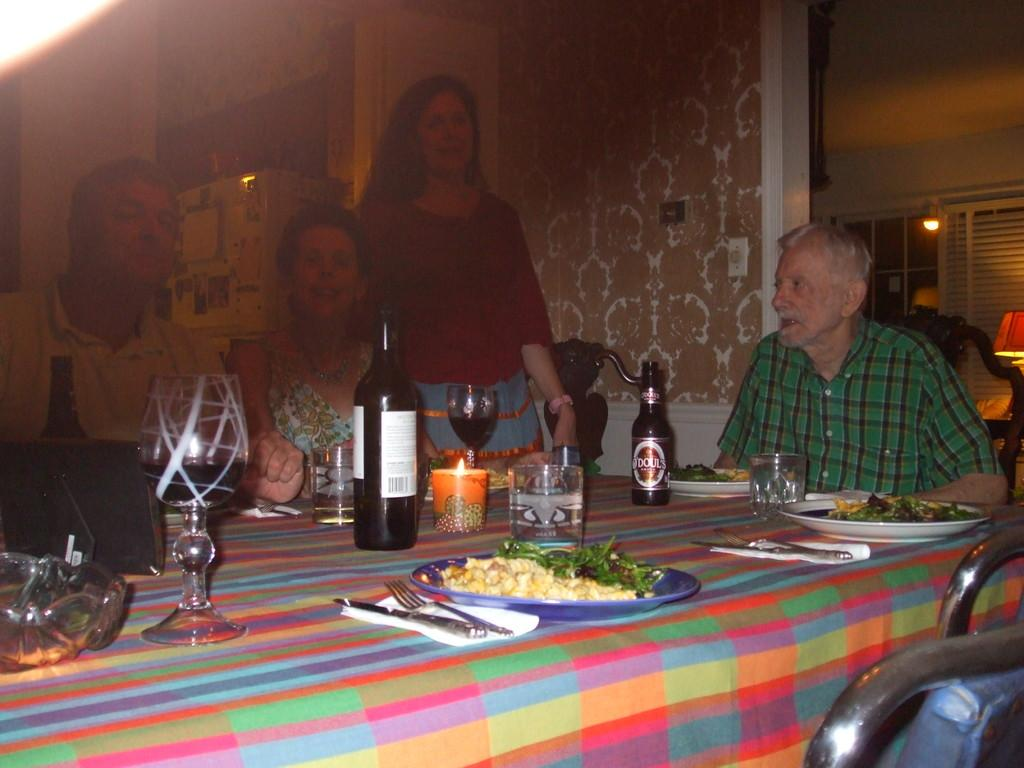How many people are in the room? There are four people in the room. What furniture or object can be found in the room? There is a table in the room. What items are on the table? There is a bottle, a plate, a tissue, a spoon, a fork, and a food item on the table. What can be seen in the background of the room? There is a curtain and a lamp in the background. What type of range can be seen in the image? There is no range present in the image. 